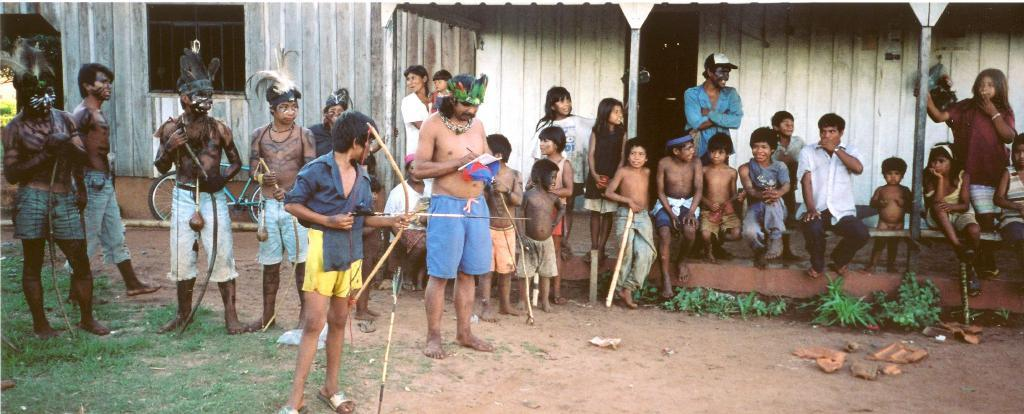How many people are present in the image? There are many people in the image. What are the people holding in their hands? The people are holding arrows. What is at the bottom of the image? There is a ground at the bottom of the image. What type of houses can be seen in the background? There are houses made of wood in the background. What type of vegetation is visible at the left bottom of the image? There is green grass at the left bottom of the image. What type of tub can be seen in the image? There is no tub present in the image. What thoughts are the people having while holding arrows in the image? The image does not provide information about the thoughts of the people holding arrows. 